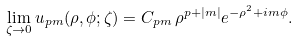Convert formula to latex. <formula><loc_0><loc_0><loc_500><loc_500>\lim _ { \zeta \rightarrow 0 } u _ { p m } ( \rho , \phi ; \zeta ) = C _ { p m } \, \rho ^ { p + | m | } e ^ { - \rho ^ { 2 } + i m \phi } .</formula> 